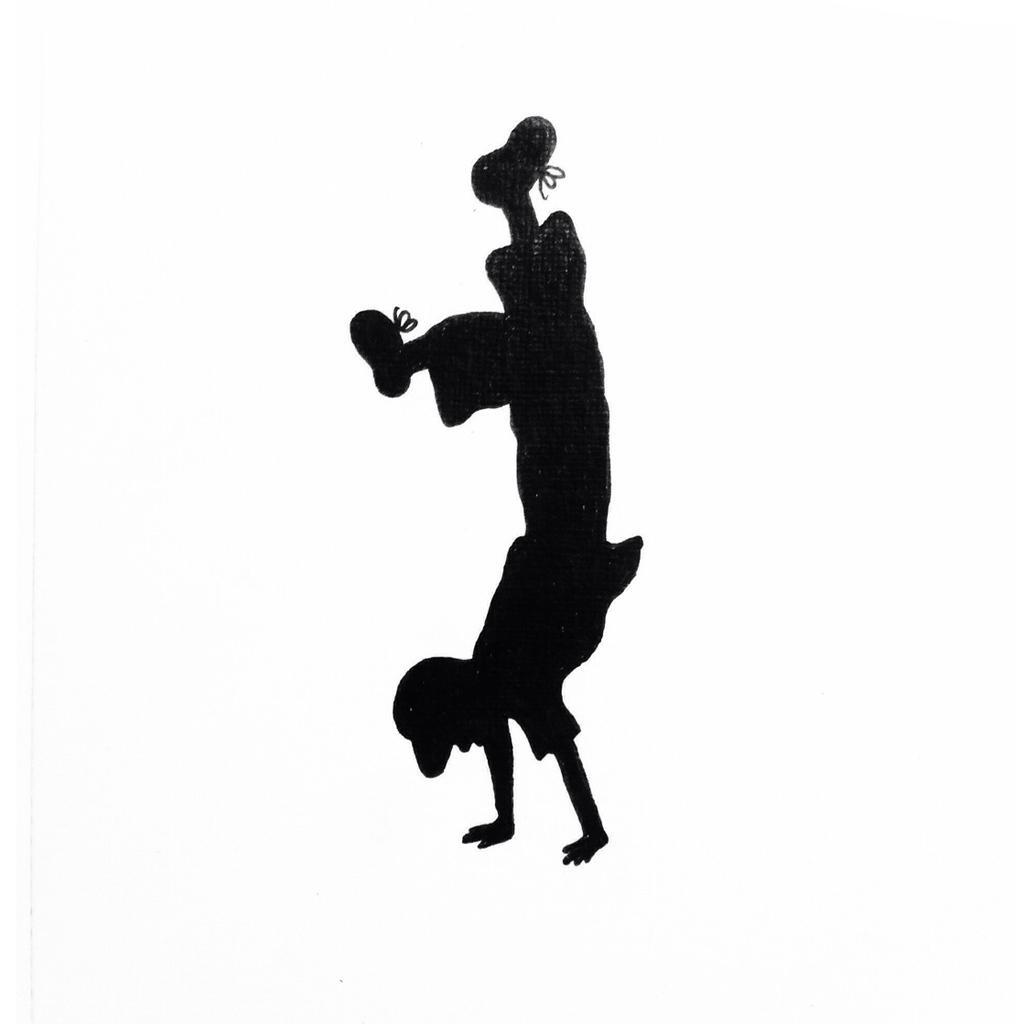Could you give a brief overview of what you see in this image? In this image there is boy in upside down position. 